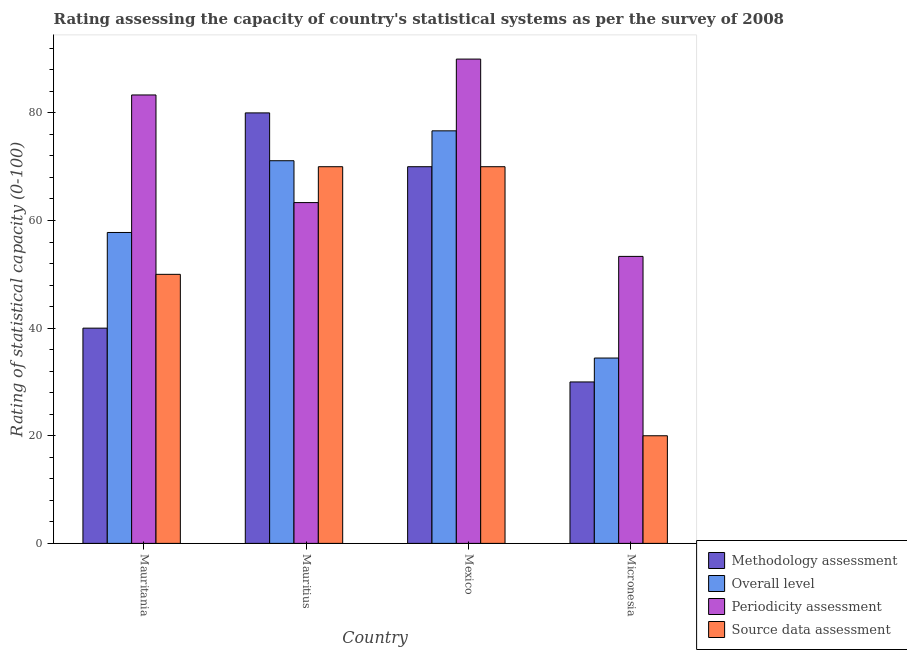How many different coloured bars are there?
Give a very brief answer. 4. How many groups of bars are there?
Offer a terse response. 4. How many bars are there on the 4th tick from the left?
Offer a terse response. 4. How many bars are there on the 1st tick from the right?
Offer a very short reply. 4. What is the label of the 4th group of bars from the left?
Provide a succinct answer. Micronesia. What is the methodology assessment rating in Mauritius?
Give a very brief answer. 80. Across all countries, what is the minimum periodicity assessment rating?
Your response must be concise. 53.33. In which country was the source data assessment rating maximum?
Your answer should be compact. Mauritius. In which country was the periodicity assessment rating minimum?
Your answer should be compact. Micronesia. What is the total periodicity assessment rating in the graph?
Offer a very short reply. 290. What is the difference between the overall level rating in Mauritania and that in Mauritius?
Provide a succinct answer. -13.33. What is the difference between the overall level rating in Micronesia and the source data assessment rating in Mauritius?
Your answer should be compact. -35.56. What is the average periodicity assessment rating per country?
Provide a succinct answer. 72.5. What is the difference between the source data assessment rating and overall level rating in Mauritania?
Your response must be concise. -7.78. What is the ratio of the periodicity assessment rating in Mauritius to that in Mexico?
Offer a terse response. 0.7. Is the difference between the periodicity assessment rating in Mexico and Micronesia greater than the difference between the source data assessment rating in Mexico and Micronesia?
Provide a short and direct response. No. What is the difference between the highest and the second highest source data assessment rating?
Your response must be concise. 0. In how many countries, is the source data assessment rating greater than the average source data assessment rating taken over all countries?
Provide a succinct answer. 2. Is it the case that in every country, the sum of the methodology assessment rating and periodicity assessment rating is greater than the sum of overall level rating and source data assessment rating?
Offer a terse response. No. What does the 3rd bar from the left in Mauritius represents?
Keep it short and to the point. Periodicity assessment. What does the 2nd bar from the right in Micronesia represents?
Offer a terse response. Periodicity assessment. How many bars are there?
Your response must be concise. 16. What is the difference between two consecutive major ticks on the Y-axis?
Give a very brief answer. 20. Does the graph contain any zero values?
Make the answer very short. No. Does the graph contain grids?
Provide a succinct answer. No. Where does the legend appear in the graph?
Your answer should be very brief. Bottom right. How many legend labels are there?
Offer a very short reply. 4. How are the legend labels stacked?
Offer a terse response. Vertical. What is the title of the graph?
Your answer should be compact. Rating assessing the capacity of country's statistical systems as per the survey of 2008 . What is the label or title of the X-axis?
Make the answer very short. Country. What is the label or title of the Y-axis?
Ensure brevity in your answer.  Rating of statistical capacity (0-100). What is the Rating of statistical capacity (0-100) of Overall level in Mauritania?
Offer a terse response. 57.78. What is the Rating of statistical capacity (0-100) of Periodicity assessment in Mauritania?
Give a very brief answer. 83.33. What is the Rating of statistical capacity (0-100) of Source data assessment in Mauritania?
Your answer should be very brief. 50. What is the Rating of statistical capacity (0-100) in Overall level in Mauritius?
Ensure brevity in your answer.  71.11. What is the Rating of statistical capacity (0-100) in Periodicity assessment in Mauritius?
Your answer should be very brief. 63.33. What is the Rating of statistical capacity (0-100) in Methodology assessment in Mexico?
Offer a very short reply. 70. What is the Rating of statistical capacity (0-100) of Overall level in Mexico?
Ensure brevity in your answer.  76.67. What is the Rating of statistical capacity (0-100) of Periodicity assessment in Mexico?
Provide a short and direct response. 90. What is the Rating of statistical capacity (0-100) of Source data assessment in Mexico?
Your answer should be compact. 70. What is the Rating of statistical capacity (0-100) of Methodology assessment in Micronesia?
Your answer should be very brief. 30. What is the Rating of statistical capacity (0-100) of Overall level in Micronesia?
Your response must be concise. 34.44. What is the Rating of statistical capacity (0-100) in Periodicity assessment in Micronesia?
Keep it short and to the point. 53.33. Across all countries, what is the maximum Rating of statistical capacity (0-100) of Overall level?
Your response must be concise. 76.67. Across all countries, what is the minimum Rating of statistical capacity (0-100) of Methodology assessment?
Provide a short and direct response. 30. Across all countries, what is the minimum Rating of statistical capacity (0-100) of Overall level?
Your answer should be compact. 34.44. Across all countries, what is the minimum Rating of statistical capacity (0-100) of Periodicity assessment?
Provide a short and direct response. 53.33. Across all countries, what is the minimum Rating of statistical capacity (0-100) of Source data assessment?
Keep it short and to the point. 20. What is the total Rating of statistical capacity (0-100) of Methodology assessment in the graph?
Give a very brief answer. 220. What is the total Rating of statistical capacity (0-100) in Overall level in the graph?
Your answer should be compact. 240. What is the total Rating of statistical capacity (0-100) of Periodicity assessment in the graph?
Your answer should be very brief. 290. What is the total Rating of statistical capacity (0-100) in Source data assessment in the graph?
Your answer should be very brief. 210. What is the difference between the Rating of statistical capacity (0-100) of Overall level in Mauritania and that in Mauritius?
Keep it short and to the point. -13.33. What is the difference between the Rating of statistical capacity (0-100) of Source data assessment in Mauritania and that in Mauritius?
Provide a succinct answer. -20. What is the difference between the Rating of statistical capacity (0-100) of Methodology assessment in Mauritania and that in Mexico?
Your answer should be very brief. -30. What is the difference between the Rating of statistical capacity (0-100) in Overall level in Mauritania and that in Mexico?
Offer a terse response. -18.89. What is the difference between the Rating of statistical capacity (0-100) of Periodicity assessment in Mauritania and that in Mexico?
Your response must be concise. -6.67. What is the difference between the Rating of statistical capacity (0-100) of Source data assessment in Mauritania and that in Mexico?
Keep it short and to the point. -20. What is the difference between the Rating of statistical capacity (0-100) in Overall level in Mauritania and that in Micronesia?
Offer a terse response. 23.33. What is the difference between the Rating of statistical capacity (0-100) of Periodicity assessment in Mauritania and that in Micronesia?
Make the answer very short. 30. What is the difference between the Rating of statistical capacity (0-100) in Overall level in Mauritius and that in Mexico?
Give a very brief answer. -5.56. What is the difference between the Rating of statistical capacity (0-100) of Periodicity assessment in Mauritius and that in Mexico?
Your answer should be compact. -26.67. What is the difference between the Rating of statistical capacity (0-100) of Source data assessment in Mauritius and that in Mexico?
Your answer should be compact. 0. What is the difference between the Rating of statistical capacity (0-100) in Overall level in Mauritius and that in Micronesia?
Offer a terse response. 36.67. What is the difference between the Rating of statistical capacity (0-100) in Periodicity assessment in Mauritius and that in Micronesia?
Give a very brief answer. 10. What is the difference between the Rating of statistical capacity (0-100) of Source data assessment in Mauritius and that in Micronesia?
Your answer should be compact. 50. What is the difference between the Rating of statistical capacity (0-100) in Methodology assessment in Mexico and that in Micronesia?
Give a very brief answer. 40. What is the difference between the Rating of statistical capacity (0-100) of Overall level in Mexico and that in Micronesia?
Offer a very short reply. 42.22. What is the difference between the Rating of statistical capacity (0-100) in Periodicity assessment in Mexico and that in Micronesia?
Ensure brevity in your answer.  36.67. What is the difference between the Rating of statistical capacity (0-100) in Methodology assessment in Mauritania and the Rating of statistical capacity (0-100) in Overall level in Mauritius?
Make the answer very short. -31.11. What is the difference between the Rating of statistical capacity (0-100) of Methodology assessment in Mauritania and the Rating of statistical capacity (0-100) of Periodicity assessment in Mauritius?
Make the answer very short. -23.33. What is the difference between the Rating of statistical capacity (0-100) in Overall level in Mauritania and the Rating of statistical capacity (0-100) in Periodicity assessment in Mauritius?
Give a very brief answer. -5.56. What is the difference between the Rating of statistical capacity (0-100) in Overall level in Mauritania and the Rating of statistical capacity (0-100) in Source data assessment in Mauritius?
Offer a very short reply. -12.22. What is the difference between the Rating of statistical capacity (0-100) in Periodicity assessment in Mauritania and the Rating of statistical capacity (0-100) in Source data assessment in Mauritius?
Your response must be concise. 13.33. What is the difference between the Rating of statistical capacity (0-100) in Methodology assessment in Mauritania and the Rating of statistical capacity (0-100) in Overall level in Mexico?
Offer a terse response. -36.67. What is the difference between the Rating of statistical capacity (0-100) of Overall level in Mauritania and the Rating of statistical capacity (0-100) of Periodicity assessment in Mexico?
Your answer should be very brief. -32.22. What is the difference between the Rating of statistical capacity (0-100) of Overall level in Mauritania and the Rating of statistical capacity (0-100) of Source data assessment in Mexico?
Offer a terse response. -12.22. What is the difference between the Rating of statistical capacity (0-100) in Periodicity assessment in Mauritania and the Rating of statistical capacity (0-100) in Source data assessment in Mexico?
Ensure brevity in your answer.  13.33. What is the difference between the Rating of statistical capacity (0-100) in Methodology assessment in Mauritania and the Rating of statistical capacity (0-100) in Overall level in Micronesia?
Offer a terse response. 5.56. What is the difference between the Rating of statistical capacity (0-100) in Methodology assessment in Mauritania and the Rating of statistical capacity (0-100) in Periodicity assessment in Micronesia?
Your answer should be very brief. -13.33. What is the difference between the Rating of statistical capacity (0-100) in Overall level in Mauritania and the Rating of statistical capacity (0-100) in Periodicity assessment in Micronesia?
Provide a short and direct response. 4.44. What is the difference between the Rating of statistical capacity (0-100) of Overall level in Mauritania and the Rating of statistical capacity (0-100) of Source data assessment in Micronesia?
Give a very brief answer. 37.78. What is the difference between the Rating of statistical capacity (0-100) in Periodicity assessment in Mauritania and the Rating of statistical capacity (0-100) in Source data assessment in Micronesia?
Offer a very short reply. 63.33. What is the difference between the Rating of statistical capacity (0-100) in Methodology assessment in Mauritius and the Rating of statistical capacity (0-100) in Source data assessment in Mexico?
Your answer should be compact. 10. What is the difference between the Rating of statistical capacity (0-100) in Overall level in Mauritius and the Rating of statistical capacity (0-100) in Periodicity assessment in Mexico?
Your answer should be very brief. -18.89. What is the difference between the Rating of statistical capacity (0-100) in Overall level in Mauritius and the Rating of statistical capacity (0-100) in Source data assessment in Mexico?
Offer a terse response. 1.11. What is the difference between the Rating of statistical capacity (0-100) of Periodicity assessment in Mauritius and the Rating of statistical capacity (0-100) of Source data assessment in Mexico?
Offer a very short reply. -6.67. What is the difference between the Rating of statistical capacity (0-100) in Methodology assessment in Mauritius and the Rating of statistical capacity (0-100) in Overall level in Micronesia?
Offer a terse response. 45.56. What is the difference between the Rating of statistical capacity (0-100) of Methodology assessment in Mauritius and the Rating of statistical capacity (0-100) of Periodicity assessment in Micronesia?
Your answer should be very brief. 26.67. What is the difference between the Rating of statistical capacity (0-100) in Methodology assessment in Mauritius and the Rating of statistical capacity (0-100) in Source data assessment in Micronesia?
Offer a terse response. 60. What is the difference between the Rating of statistical capacity (0-100) in Overall level in Mauritius and the Rating of statistical capacity (0-100) in Periodicity assessment in Micronesia?
Your answer should be very brief. 17.78. What is the difference between the Rating of statistical capacity (0-100) of Overall level in Mauritius and the Rating of statistical capacity (0-100) of Source data assessment in Micronesia?
Provide a succinct answer. 51.11. What is the difference between the Rating of statistical capacity (0-100) in Periodicity assessment in Mauritius and the Rating of statistical capacity (0-100) in Source data assessment in Micronesia?
Provide a succinct answer. 43.33. What is the difference between the Rating of statistical capacity (0-100) of Methodology assessment in Mexico and the Rating of statistical capacity (0-100) of Overall level in Micronesia?
Give a very brief answer. 35.56. What is the difference between the Rating of statistical capacity (0-100) in Methodology assessment in Mexico and the Rating of statistical capacity (0-100) in Periodicity assessment in Micronesia?
Make the answer very short. 16.67. What is the difference between the Rating of statistical capacity (0-100) in Overall level in Mexico and the Rating of statistical capacity (0-100) in Periodicity assessment in Micronesia?
Offer a terse response. 23.33. What is the difference between the Rating of statistical capacity (0-100) in Overall level in Mexico and the Rating of statistical capacity (0-100) in Source data assessment in Micronesia?
Your answer should be compact. 56.67. What is the difference between the Rating of statistical capacity (0-100) in Periodicity assessment in Mexico and the Rating of statistical capacity (0-100) in Source data assessment in Micronesia?
Offer a terse response. 70. What is the average Rating of statistical capacity (0-100) in Methodology assessment per country?
Offer a terse response. 55. What is the average Rating of statistical capacity (0-100) in Periodicity assessment per country?
Give a very brief answer. 72.5. What is the average Rating of statistical capacity (0-100) in Source data assessment per country?
Provide a short and direct response. 52.5. What is the difference between the Rating of statistical capacity (0-100) of Methodology assessment and Rating of statistical capacity (0-100) of Overall level in Mauritania?
Your answer should be compact. -17.78. What is the difference between the Rating of statistical capacity (0-100) in Methodology assessment and Rating of statistical capacity (0-100) in Periodicity assessment in Mauritania?
Make the answer very short. -43.33. What is the difference between the Rating of statistical capacity (0-100) of Overall level and Rating of statistical capacity (0-100) of Periodicity assessment in Mauritania?
Your answer should be compact. -25.56. What is the difference between the Rating of statistical capacity (0-100) in Overall level and Rating of statistical capacity (0-100) in Source data assessment in Mauritania?
Provide a succinct answer. 7.78. What is the difference between the Rating of statistical capacity (0-100) of Periodicity assessment and Rating of statistical capacity (0-100) of Source data assessment in Mauritania?
Your answer should be compact. 33.33. What is the difference between the Rating of statistical capacity (0-100) of Methodology assessment and Rating of statistical capacity (0-100) of Overall level in Mauritius?
Offer a terse response. 8.89. What is the difference between the Rating of statistical capacity (0-100) of Methodology assessment and Rating of statistical capacity (0-100) of Periodicity assessment in Mauritius?
Offer a very short reply. 16.67. What is the difference between the Rating of statistical capacity (0-100) in Methodology assessment and Rating of statistical capacity (0-100) in Source data assessment in Mauritius?
Your answer should be very brief. 10. What is the difference between the Rating of statistical capacity (0-100) in Overall level and Rating of statistical capacity (0-100) in Periodicity assessment in Mauritius?
Ensure brevity in your answer.  7.78. What is the difference between the Rating of statistical capacity (0-100) in Overall level and Rating of statistical capacity (0-100) in Source data assessment in Mauritius?
Provide a short and direct response. 1.11. What is the difference between the Rating of statistical capacity (0-100) of Periodicity assessment and Rating of statistical capacity (0-100) of Source data assessment in Mauritius?
Your answer should be very brief. -6.67. What is the difference between the Rating of statistical capacity (0-100) of Methodology assessment and Rating of statistical capacity (0-100) of Overall level in Mexico?
Ensure brevity in your answer.  -6.67. What is the difference between the Rating of statistical capacity (0-100) of Methodology assessment and Rating of statistical capacity (0-100) of Source data assessment in Mexico?
Your answer should be very brief. 0. What is the difference between the Rating of statistical capacity (0-100) in Overall level and Rating of statistical capacity (0-100) in Periodicity assessment in Mexico?
Your answer should be compact. -13.33. What is the difference between the Rating of statistical capacity (0-100) of Overall level and Rating of statistical capacity (0-100) of Source data assessment in Mexico?
Your response must be concise. 6.67. What is the difference between the Rating of statistical capacity (0-100) of Periodicity assessment and Rating of statistical capacity (0-100) of Source data assessment in Mexico?
Provide a succinct answer. 20. What is the difference between the Rating of statistical capacity (0-100) of Methodology assessment and Rating of statistical capacity (0-100) of Overall level in Micronesia?
Make the answer very short. -4.44. What is the difference between the Rating of statistical capacity (0-100) of Methodology assessment and Rating of statistical capacity (0-100) of Periodicity assessment in Micronesia?
Offer a very short reply. -23.33. What is the difference between the Rating of statistical capacity (0-100) of Overall level and Rating of statistical capacity (0-100) of Periodicity assessment in Micronesia?
Your answer should be compact. -18.89. What is the difference between the Rating of statistical capacity (0-100) in Overall level and Rating of statistical capacity (0-100) in Source data assessment in Micronesia?
Your answer should be compact. 14.44. What is the difference between the Rating of statistical capacity (0-100) of Periodicity assessment and Rating of statistical capacity (0-100) of Source data assessment in Micronesia?
Your answer should be very brief. 33.33. What is the ratio of the Rating of statistical capacity (0-100) of Overall level in Mauritania to that in Mauritius?
Make the answer very short. 0.81. What is the ratio of the Rating of statistical capacity (0-100) of Periodicity assessment in Mauritania to that in Mauritius?
Provide a short and direct response. 1.32. What is the ratio of the Rating of statistical capacity (0-100) in Source data assessment in Mauritania to that in Mauritius?
Keep it short and to the point. 0.71. What is the ratio of the Rating of statistical capacity (0-100) in Methodology assessment in Mauritania to that in Mexico?
Your answer should be very brief. 0.57. What is the ratio of the Rating of statistical capacity (0-100) of Overall level in Mauritania to that in Mexico?
Provide a short and direct response. 0.75. What is the ratio of the Rating of statistical capacity (0-100) of Periodicity assessment in Mauritania to that in Mexico?
Provide a succinct answer. 0.93. What is the ratio of the Rating of statistical capacity (0-100) in Source data assessment in Mauritania to that in Mexico?
Your answer should be compact. 0.71. What is the ratio of the Rating of statistical capacity (0-100) of Overall level in Mauritania to that in Micronesia?
Your answer should be compact. 1.68. What is the ratio of the Rating of statistical capacity (0-100) in Periodicity assessment in Mauritania to that in Micronesia?
Provide a short and direct response. 1.56. What is the ratio of the Rating of statistical capacity (0-100) of Methodology assessment in Mauritius to that in Mexico?
Provide a succinct answer. 1.14. What is the ratio of the Rating of statistical capacity (0-100) of Overall level in Mauritius to that in Mexico?
Make the answer very short. 0.93. What is the ratio of the Rating of statistical capacity (0-100) in Periodicity assessment in Mauritius to that in Mexico?
Offer a very short reply. 0.7. What is the ratio of the Rating of statistical capacity (0-100) in Methodology assessment in Mauritius to that in Micronesia?
Offer a very short reply. 2.67. What is the ratio of the Rating of statistical capacity (0-100) in Overall level in Mauritius to that in Micronesia?
Your answer should be compact. 2.06. What is the ratio of the Rating of statistical capacity (0-100) of Periodicity assessment in Mauritius to that in Micronesia?
Make the answer very short. 1.19. What is the ratio of the Rating of statistical capacity (0-100) in Methodology assessment in Mexico to that in Micronesia?
Keep it short and to the point. 2.33. What is the ratio of the Rating of statistical capacity (0-100) in Overall level in Mexico to that in Micronesia?
Your answer should be very brief. 2.23. What is the ratio of the Rating of statistical capacity (0-100) in Periodicity assessment in Mexico to that in Micronesia?
Provide a succinct answer. 1.69. What is the difference between the highest and the second highest Rating of statistical capacity (0-100) in Overall level?
Your response must be concise. 5.56. What is the difference between the highest and the lowest Rating of statistical capacity (0-100) in Methodology assessment?
Provide a succinct answer. 50. What is the difference between the highest and the lowest Rating of statistical capacity (0-100) of Overall level?
Your answer should be compact. 42.22. What is the difference between the highest and the lowest Rating of statistical capacity (0-100) in Periodicity assessment?
Offer a terse response. 36.67. What is the difference between the highest and the lowest Rating of statistical capacity (0-100) in Source data assessment?
Provide a succinct answer. 50. 